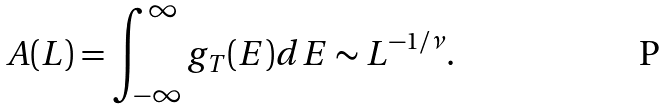Convert formula to latex. <formula><loc_0><loc_0><loc_500><loc_500>A ( L ) = \int _ { - \infty } ^ { \infty } g _ { T } ( E ) d E \sim L ^ { - 1 / \nu } .</formula> 